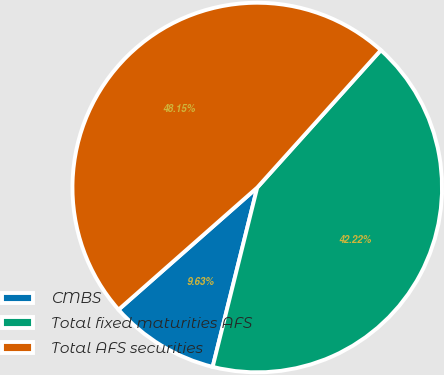<chart> <loc_0><loc_0><loc_500><loc_500><pie_chart><fcel>CMBS<fcel>Total fixed maturities AFS<fcel>Total AFS securities<nl><fcel>9.63%<fcel>42.22%<fcel>48.15%<nl></chart> 